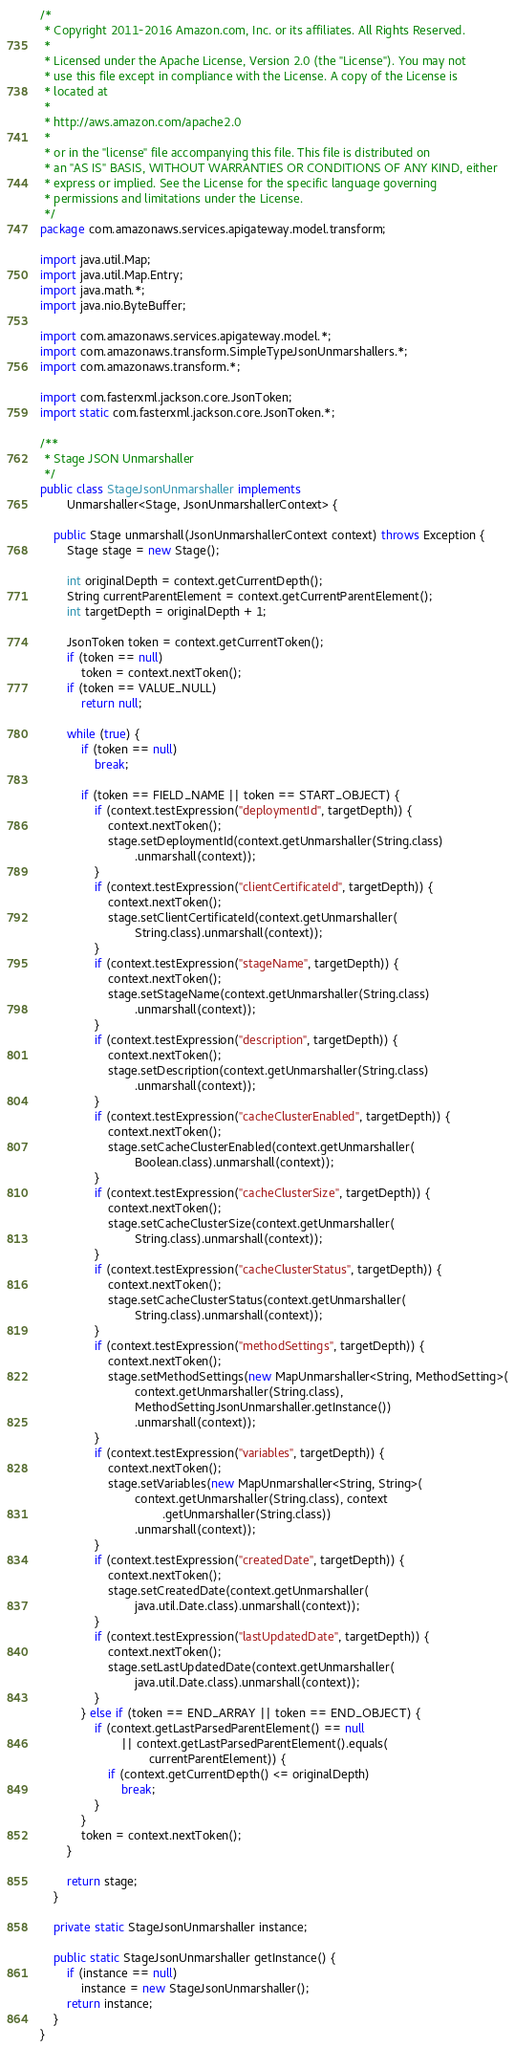<code> <loc_0><loc_0><loc_500><loc_500><_Java_>/*
 * Copyright 2011-2016 Amazon.com, Inc. or its affiliates. All Rights Reserved.
 * 
 * Licensed under the Apache License, Version 2.0 (the "License"). You may not
 * use this file except in compliance with the License. A copy of the License is
 * located at
 * 
 * http://aws.amazon.com/apache2.0
 * 
 * or in the "license" file accompanying this file. This file is distributed on
 * an "AS IS" BASIS, WITHOUT WARRANTIES OR CONDITIONS OF ANY KIND, either
 * express or implied. See the License for the specific language governing
 * permissions and limitations under the License.
 */
package com.amazonaws.services.apigateway.model.transform;

import java.util.Map;
import java.util.Map.Entry;
import java.math.*;
import java.nio.ByteBuffer;

import com.amazonaws.services.apigateway.model.*;
import com.amazonaws.transform.SimpleTypeJsonUnmarshallers.*;
import com.amazonaws.transform.*;

import com.fasterxml.jackson.core.JsonToken;
import static com.fasterxml.jackson.core.JsonToken.*;

/**
 * Stage JSON Unmarshaller
 */
public class StageJsonUnmarshaller implements
        Unmarshaller<Stage, JsonUnmarshallerContext> {

    public Stage unmarshall(JsonUnmarshallerContext context) throws Exception {
        Stage stage = new Stage();

        int originalDepth = context.getCurrentDepth();
        String currentParentElement = context.getCurrentParentElement();
        int targetDepth = originalDepth + 1;

        JsonToken token = context.getCurrentToken();
        if (token == null)
            token = context.nextToken();
        if (token == VALUE_NULL)
            return null;

        while (true) {
            if (token == null)
                break;

            if (token == FIELD_NAME || token == START_OBJECT) {
                if (context.testExpression("deploymentId", targetDepth)) {
                    context.nextToken();
                    stage.setDeploymentId(context.getUnmarshaller(String.class)
                            .unmarshall(context));
                }
                if (context.testExpression("clientCertificateId", targetDepth)) {
                    context.nextToken();
                    stage.setClientCertificateId(context.getUnmarshaller(
                            String.class).unmarshall(context));
                }
                if (context.testExpression("stageName", targetDepth)) {
                    context.nextToken();
                    stage.setStageName(context.getUnmarshaller(String.class)
                            .unmarshall(context));
                }
                if (context.testExpression("description", targetDepth)) {
                    context.nextToken();
                    stage.setDescription(context.getUnmarshaller(String.class)
                            .unmarshall(context));
                }
                if (context.testExpression("cacheClusterEnabled", targetDepth)) {
                    context.nextToken();
                    stage.setCacheClusterEnabled(context.getUnmarshaller(
                            Boolean.class).unmarshall(context));
                }
                if (context.testExpression("cacheClusterSize", targetDepth)) {
                    context.nextToken();
                    stage.setCacheClusterSize(context.getUnmarshaller(
                            String.class).unmarshall(context));
                }
                if (context.testExpression("cacheClusterStatus", targetDepth)) {
                    context.nextToken();
                    stage.setCacheClusterStatus(context.getUnmarshaller(
                            String.class).unmarshall(context));
                }
                if (context.testExpression("methodSettings", targetDepth)) {
                    context.nextToken();
                    stage.setMethodSettings(new MapUnmarshaller<String, MethodSetting>(
                            context.getUnmarshaller(String.class),
                            MethodSettingJsonUnmarshaller.getInstance())
                            .unmarshall(context));
                }
                if (context.testExpression("variables", targetDepth)) {
                    context.nextToken();
                    stage.setVariables(new MapUnmarshaller<String, String>(
                            context.getUnmarshaller(String.class), context
                                    .getUnmarshaller(String.class))
                            .unmarshall(context));
                }
                if (context.testExpression("createdDate", targetDepth)) {
                    context.nextToken();
                    stage.setCreatedDate(context.getUnmarshaller(
                            java.util.Date.class).unmarshall(context));
                }
                if (context.testExpression("lastUpdatedDate", targetDepth)) {
                    context.nextToken();
                    stage.setLastUpdatedDate(context.getUnmarshaller(
                            java.util.Date.class).unmarshall(context));
                }
            } else if (token == END_ARRAY || token == END_OBJECT) {
                if (context.getLastParsedParentElement() == null
                        || context.getLastParsedParentElement().equals(
                                currentParentElement)) {
                    if (context.getCurrentDepth() <= originalDepth)
                        break;
                }
            }
            token = context.nextToken();
        }

        return stage;
    }

    private static StageJsonUnmarshaller instance;

    public static StageJsonUnmarshaller getInstance() {
        if (instance == null)
            instance = new StageJsonUnmarshaller();
        return instance;
    }
}
</code> 